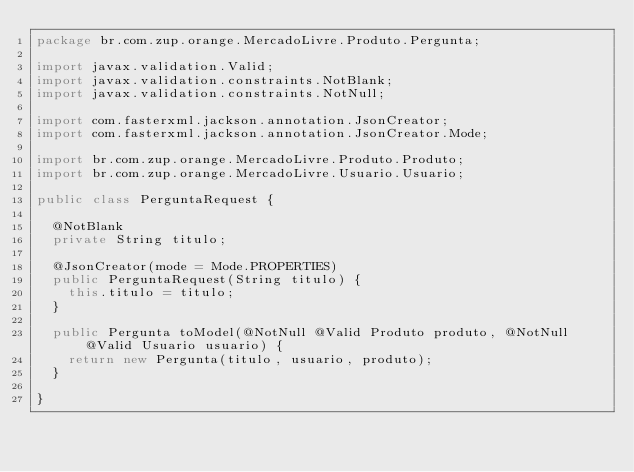Convert code to text. <code><loc_0><loc_0><loc_500><loc_500><_Java_>package br.com.zup.orange.MercadoLivre.Produto.Pergunta;

import javax.validation.Valid;
import javax.validation.constraints.NotBlank;
import javax.validation.constraints.NotNull;

import com.fasterxml.jackson.annotation.JsonCreator;
import com.fasterxml.jackson.annotation.JsonCreator.Mode;

import br.com.zup.orange.MercadoLivre.Produto.Produto;
import br.com.zup.orange.MercadoLivre.Usuario.Usuario;

public class PerguntaRequest {

	@NotBlank
	private String titulo;

	@JsonCreator(mode = Mode.PROPERTIES)
	public PerguntaRequest(String titulo) {
		this.titulo = titulo;
	}

	public Pergunta toModel(@NotNull @Valid Produto produto, @NotNull @Valid Usuario usuario) {
		return new Pergunta(titulo, usuario, produto);
	}

}
</code> 